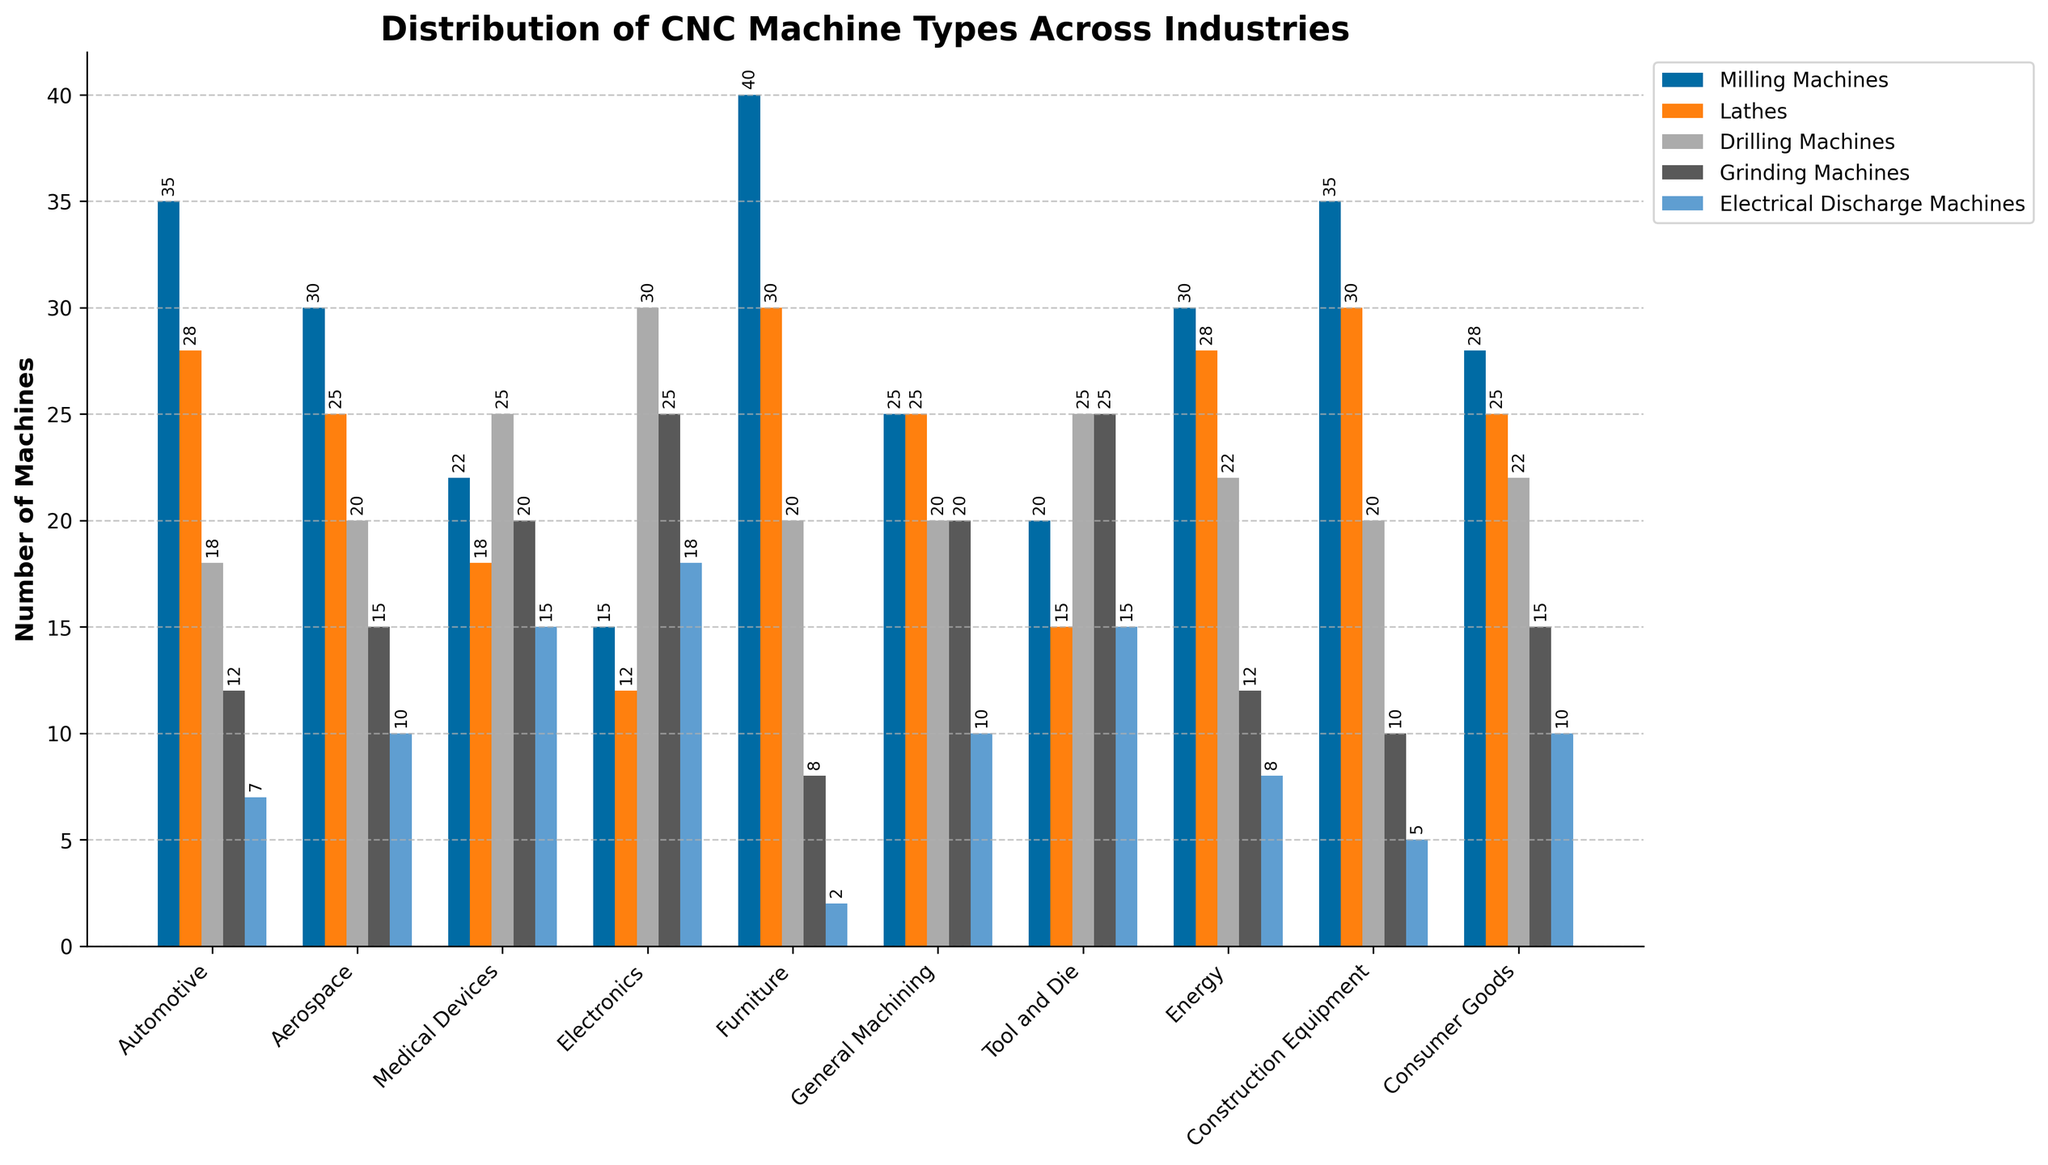Which industry has the highest number of Milling Machines? From the figure, the height of the bar representing Milling Machines is highest for the Furniture industry. Compare the heights of the Milling Machines bars across all industries and note that the Furniture industry has the tallest bar.
Answer: Furniture Which industry has the least number of Electrical Discharge Machines? The height of the bar representing Electrical Discharge Machines is lowest for the Furniture industry. Compare the heights of the bars for Electrical Discharge Machines across all industries and find the shortest one.
Answer: Furniture What is the total number of Lathes in the Automotive and Aerospace industries? Add the numbers for Lathes in the Automotive industry (28) and the Aerospace industry (25). The sum is 28 + 25 = 53.
Answer: 53 Which industry has more Drilling Machines, Medical Devices or Electronics? Compare the heights of the Drilling Machines bars for Medical Devices and Electronics. The Medical Devices bar is higher at 25, compared to Electronics at 30.
Answer: Electronics In which industry is the number of Grinding Machines the same as the number of Electrical Discharge Machines? The bar heights for Grinding Machines and Electrical Discharge Machines are equal in the Tool and Die industry, both at 25.
Answer: Tool and Die Which industry shows an equal number of Lathes and Grinding Machines? The General Machining industry shows equal heights for Lathes and Grinding Machines bars, both at 25.
Answer: General Machining What is the overall number of CNC machines in the Consumer Goods industry? Sum all the machine counts for the Consumer Goods industry: 28 (Milling Machines) + 25 (Lathes) + 22 (Drilling Machines) + 15 (Grinding Machines) + 10 (Electrical Discharge Machines) = 100.
Answer: 100 Which industry has the second-highest number of Drilling Machines? The Electronics industry has the highest bar for Drilling Machines (30), followed by Medical Devices with the second-highest bar (25).
Answer: Medical Devices How many more Milling Machines are there in the Automotive industry compared to the Energy industry? Subtract the number of Milling Machines in the Energy industry (30) from the number in the Automotive industry (35). The difference is 35 - 30 = 5.
Answer: 5 Which industry has fewer Grinding Machines than Electrical Discharge Machines but more than Milling Machines? In the Electronics industry, the bar for Grinding Machines (25) is taller than for Milling Machines (15) but shorter than for Electrical Discharge Machines (30).
Answer: Electronics 